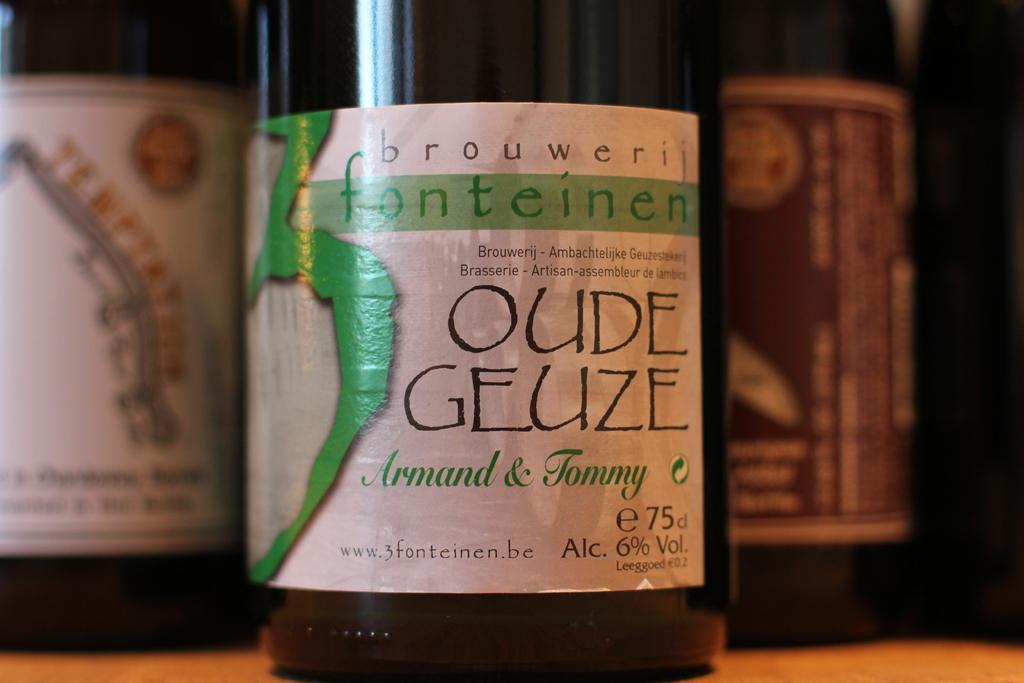What is the brand of the beverage?
Ensure brevity in your answer.  Brouwerij fonteinen. 